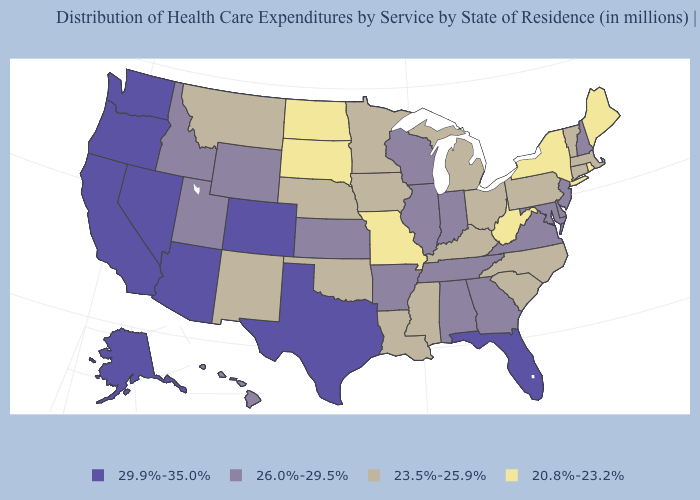What is the lowest value in the West?
Give a very brief answer. 23.5%-25.9%. Does the first symbol in the legend represent the smallest category?
Answer briefly. No. What is the value of Oklahoma?
Concise answer only. 23.5%-25.9%. Among the states that border Florida , which have the lowest value?
Give a very brief answer. Alabama, Georgia. What is the value of Idaho?
Give a very brief answer. 26.0%-29.5%. Name the states that have a value in the range 29.9%-35.0%?
Write a very short answer. Alaska, Arizona, California, Colorado, Florida, Nevada, Oregon, Texas, Washington. What is the value of Rhode Island?
Be succinct. 20.8%-23.2%. Does Nevada have the lowest value in the USA?
Answer briefly. No. Among the states that border Ohio , which have the highest value?
Short answer required. Indiana. Does Virginia have the same value as Nebraska?
Short answer required. No. Name the states that have a value in the range 29.9%-35.0%?
Write a very short answer. Alaska, Arizona, California, Colorado, Florida, Nevada, Oregon, Texas, Washington. What is the value of Hawaii?
Short answer required. 26.0%-29.5%. What is the value of Michigan?
Answer briefly. 23.5%-25.9%. Name the states that have a value in the range 23.5%-25.9%?
Give a very brief answer. Connecticut, Iowa, Kentucky, Louisiana, Massachusetts, Michigan, Minnesota, Mississippi, Montana, Nebraska, New Mexico, North Carolina, Ohio, Oklahoma, Pennsylvania, South Carolina, Vermont. Does North Dakota have a higher value than Louisiana?
Write a very short answer. No. 